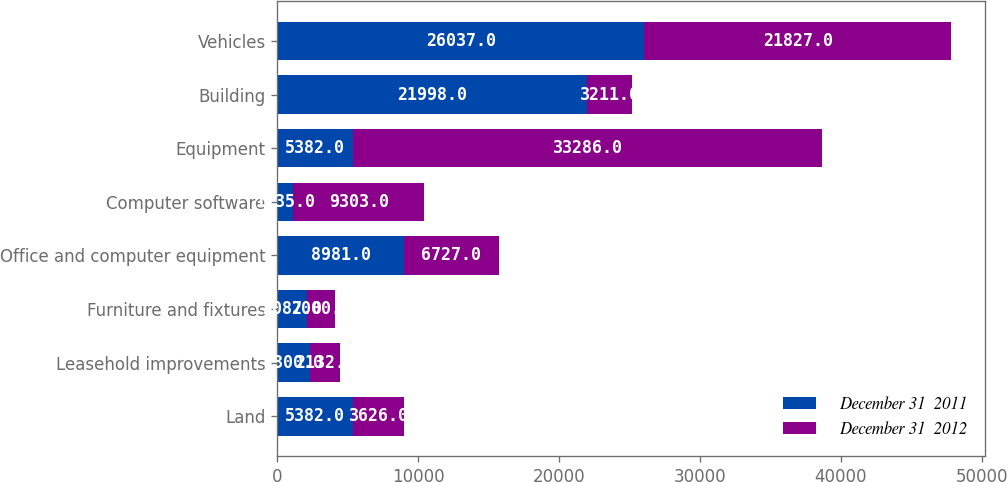Convert chart to OTSL. <chart><loc_0><loc_0><loc_500><loc_500><stacked_bar_chart><ecel><fcel>Land<fcel>Leasehold improvements<fcel>Furniture and fixtures<fcel>Office and computer equipment<fcel>Computer software<fcel>Equipment<fcel>Building<fcel>Vehicles<nl><fcel>December 31  2011<fcel>5382<fcel>2300<fcel>2087<fcel>8981<fcel>1135<fcel>5382<fcel>21998<fcel>26037<nl><fcel>December 31  2012<fcel>3626<fcel>2132<fcel>2000<fcel>6727<fcel>9303<fcel>33286<fcel>3211<fcel>21827<nl></chart> 